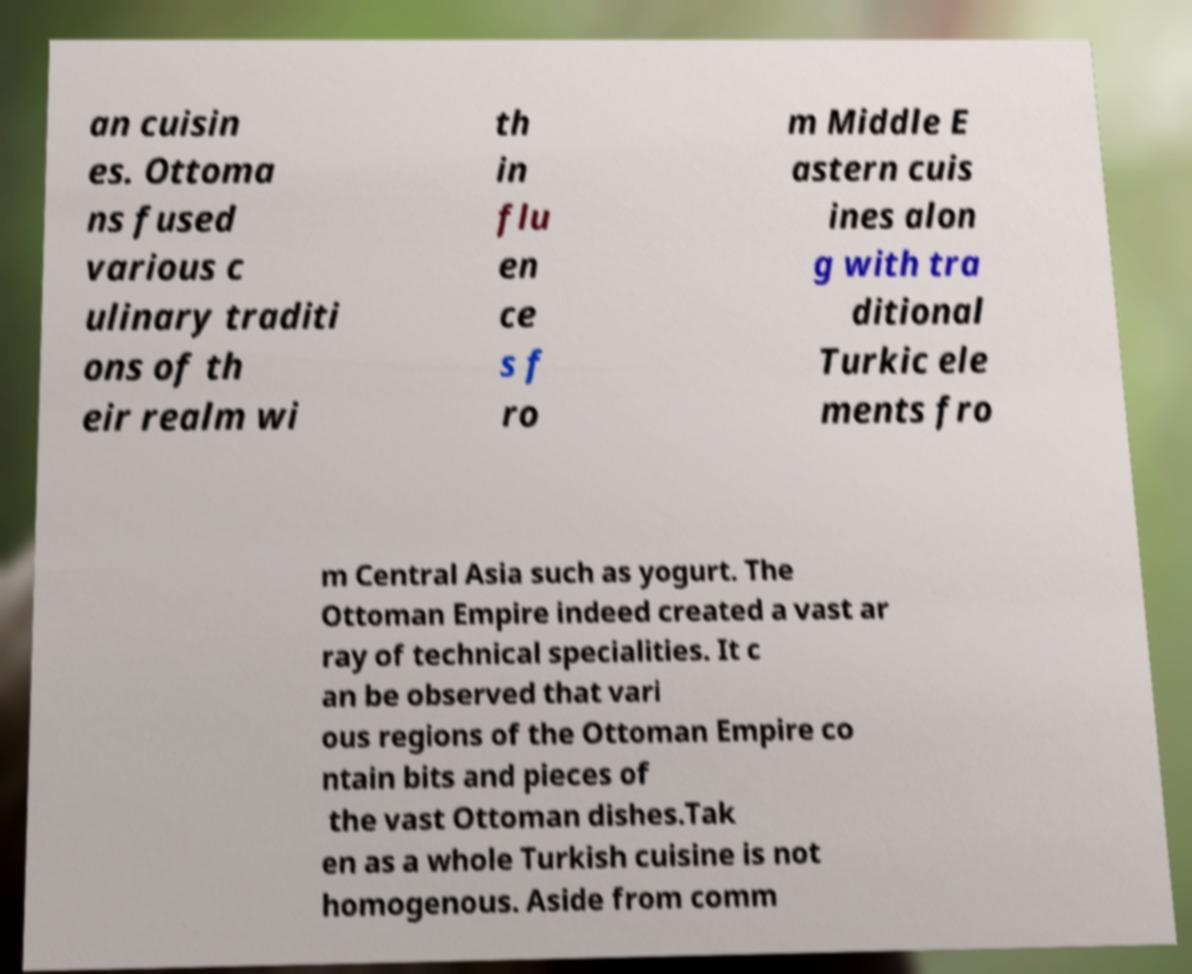Could you assist in decoding the text presented in this image and type it out clearly? an cuisin es. Ottoma ns fused various c ulinary traditi ons of th eir realm wi th in flu en ce s f ro m Middle E astern cuis ines alon g with tra ditional Turkic ele ments fro m Central Asia such as yogurt. The Ottoman Empire indeed created a vast ar ray of technical specialities. It c an be observed that vari ous regions of the Ottoman Empire co ntain bits and pieces of the vast Ottoman dishes.Tak en as a whole Turkish cuisine is not homogenous. Aside from comm 